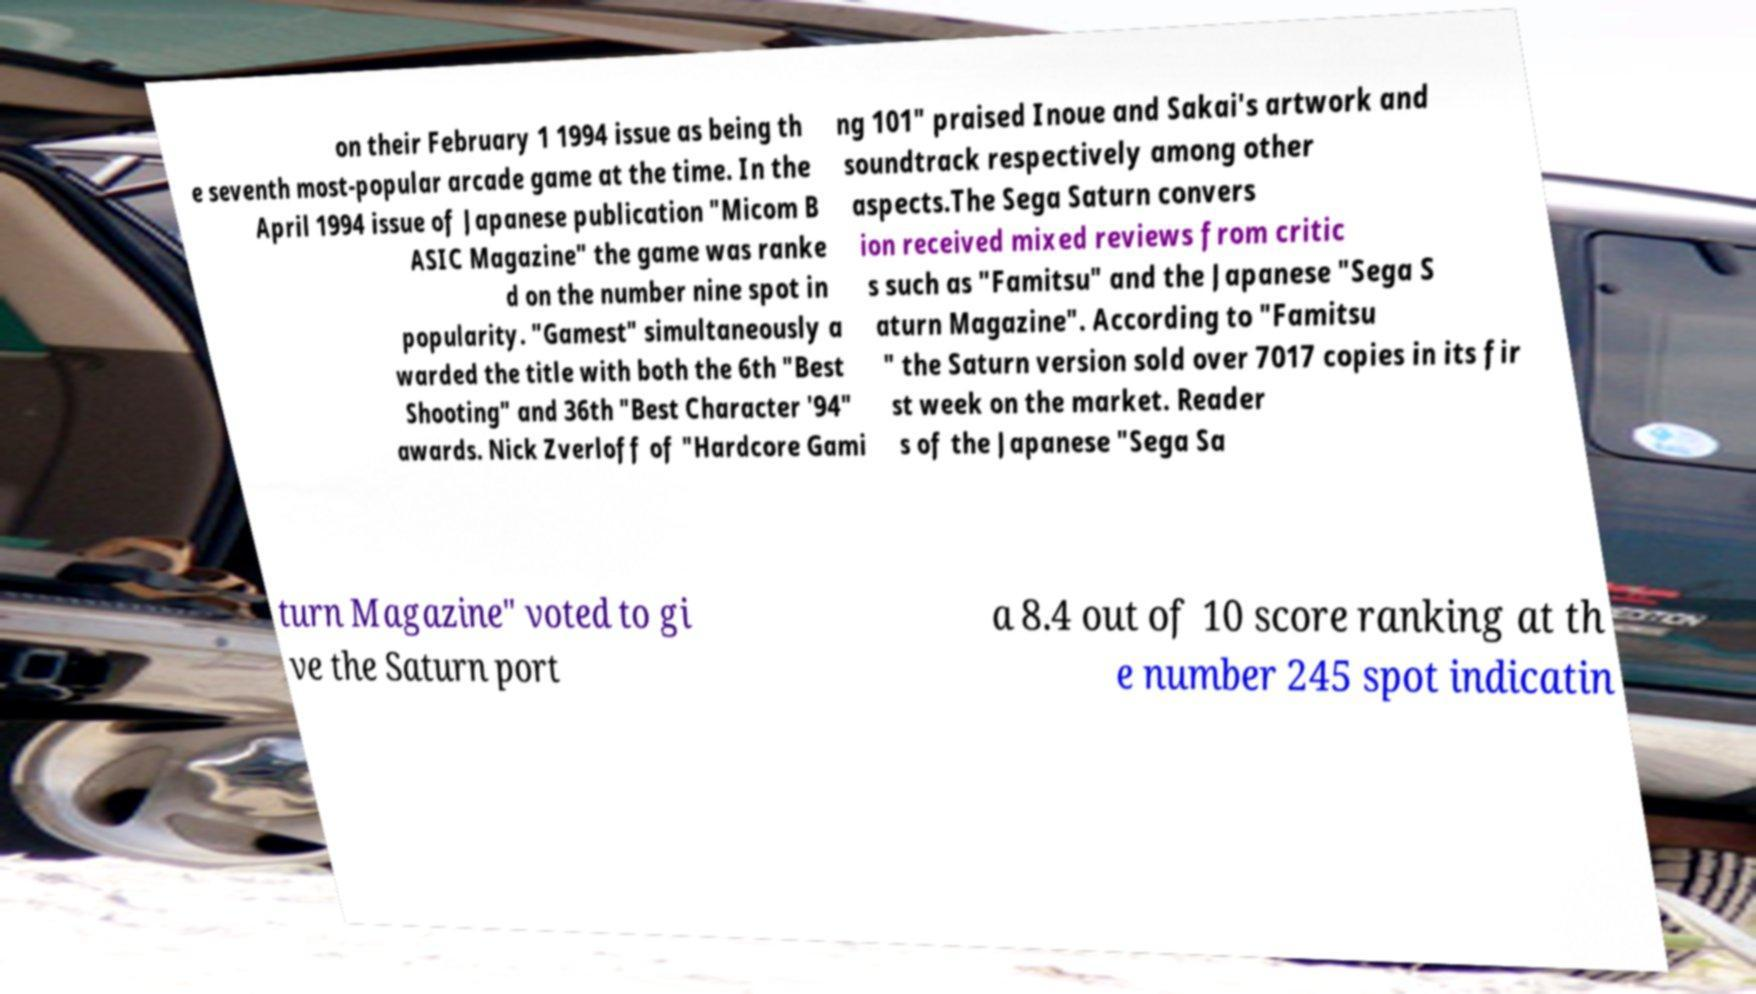Could you assist in decoding the text presented in this image and type it out clearly? on their February 1 1994 issue as being th e seventh most-popular arcade game at the time. In the April 1994 issue of Japanese publication "Micom B ASIC Magazine" the game was ranke d on the number nine spot in popularity. "Gamest" simultaneously a warded the title with both the 6th "Best Shooting" and 36th "Best Character '94" awards. Nick Zverloff of "Hardcore Gami ng 101" praised Inoue and Sakai's artwork and soundtrack respectively among other aspects.The Sega Saturn convers ion received mixed reviews from critic s such as "Famitsu" and the Japanese "Sega S aturn Magazine". According to "Famitsu " the Saturn version sold over 7017 copies in its fir st week on the market. Reader s of the Japanese "Sega Sa turn Magazine" voted to gi ve the Saturn port a 8.4 out of 10 score ranking at th e number 245 spot indicatin 